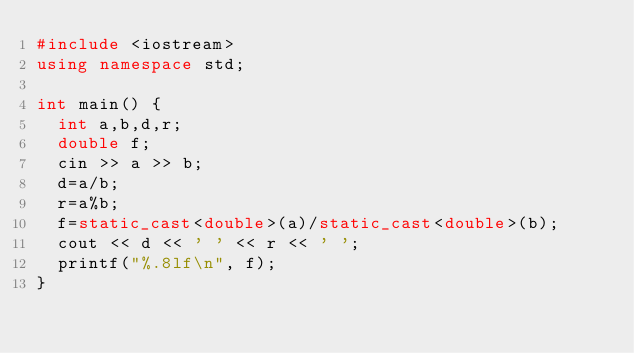<code> <loc_0><loc_0><loc_500><loc_500><_C++_>#include <iostream>
using namespace std;

int main() {
  int a,b,d,r;
  double f;
  cin >> a >> b;
  d=a/b;
  r=a%b; 
  f=static_cast<double>(a)/static_cast<double>(b);
  cout << d << ' ' << r << ' ';
  printf("%.8lf\n", f);
}
</code> 